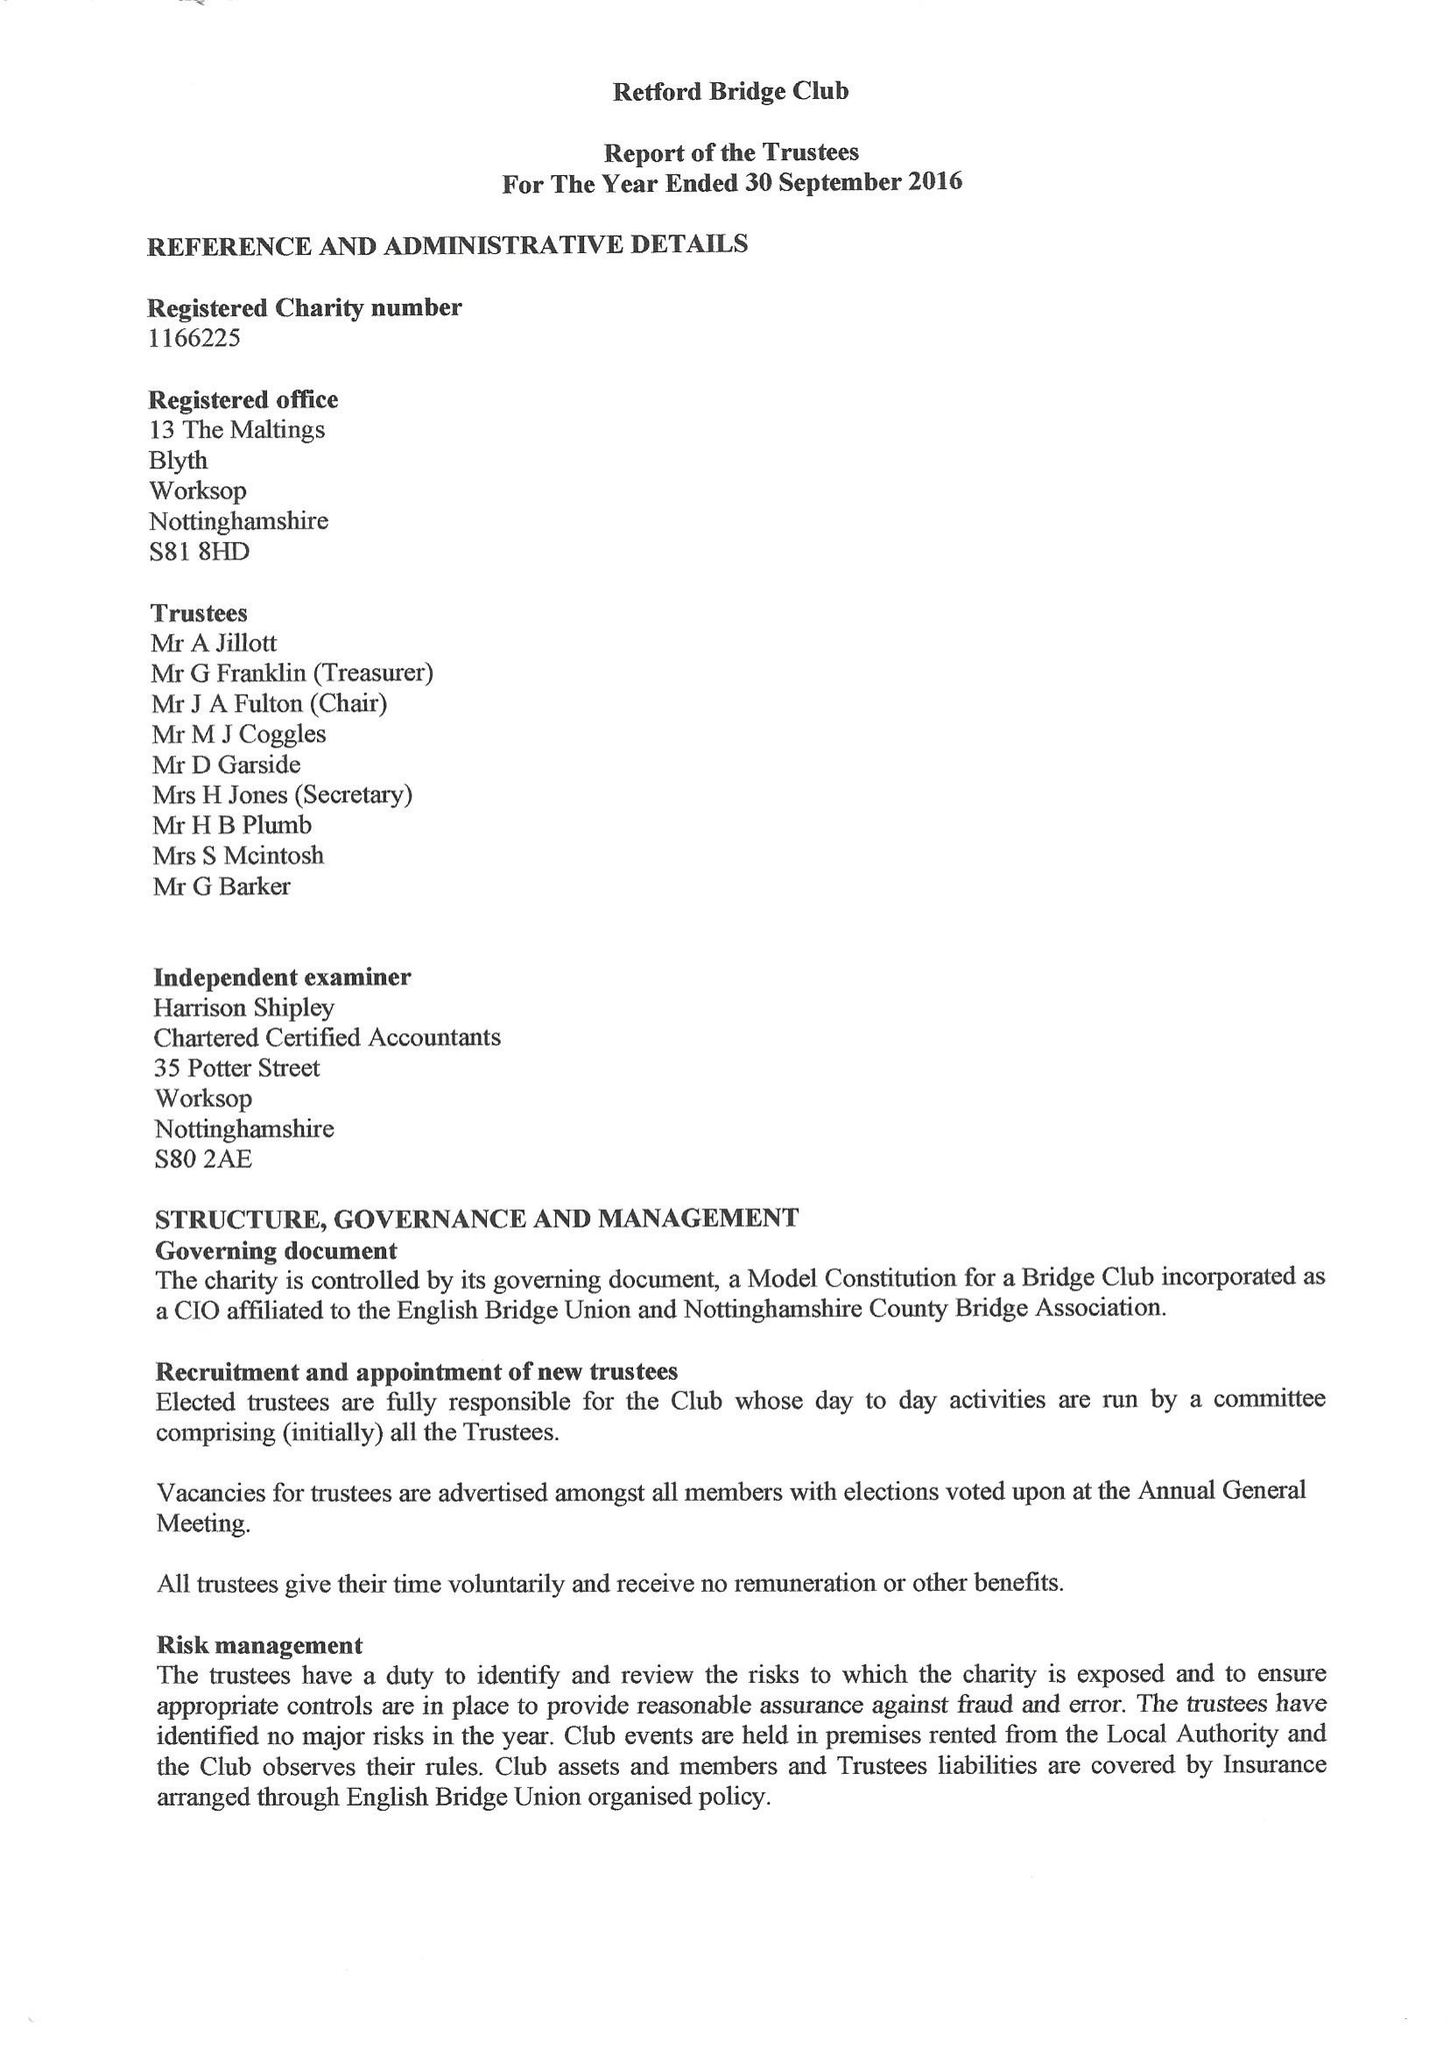What is the value for the address__street_line?
Answer the question using a single word or phrase. 13 THE MALTINGS 